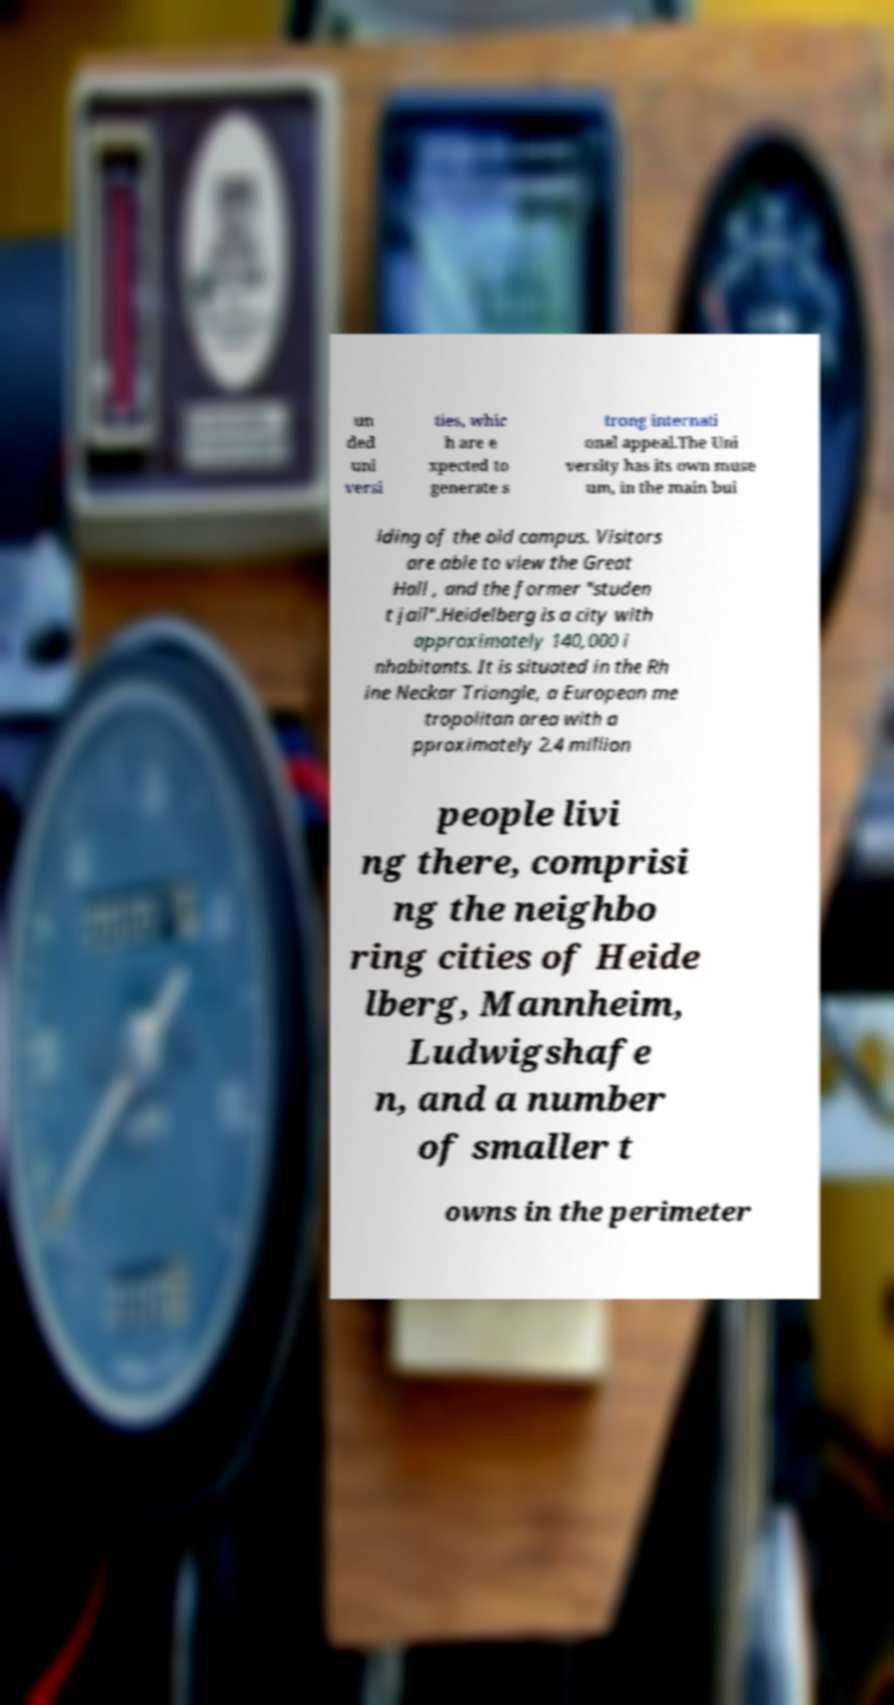Could you extract and type out the text from this image? un ded uni versi ties, whic h are e xpected to generate s trong internati onal appeal.The Uni versity has its own muse um, in the main bui lding of the old campus. Visitors are able to view the Great Hall , and the former "studen t jail".Heidelberg is a city with approximately 140,000 i nhabitants. It is situated in the Rh ine Neckar Triangle, a European me tropolitan area with a pproximately 2.4 million people livi ng there, comprisi ng the neighbo ring cities of Heide lberg, Mannheim, Ludwigshafe n, and a number of smaller t owns in the perimeter 